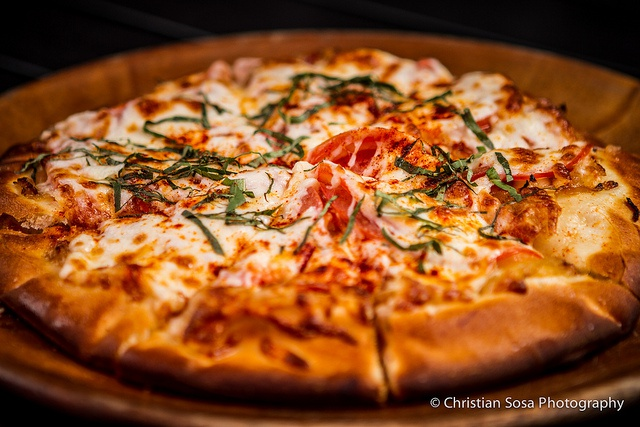Describe the objects in this image and their specific colors. I can see a pizza in black, red, maroon, brown, and tan tones in this image. 